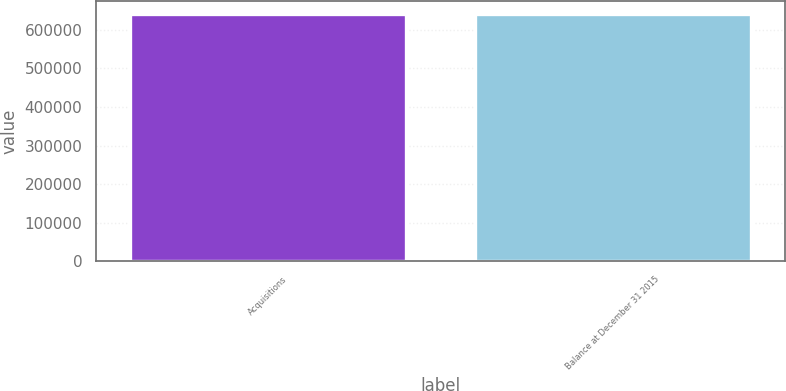Convert chart to OTSL. <chart><loc_0><loc_0><loc_500><loc_500><bar_chart><fcel>Acquisitions<fcel>Balance at December 31 2015<nl><fcel>641716<fcel>641716<nl></chart> 